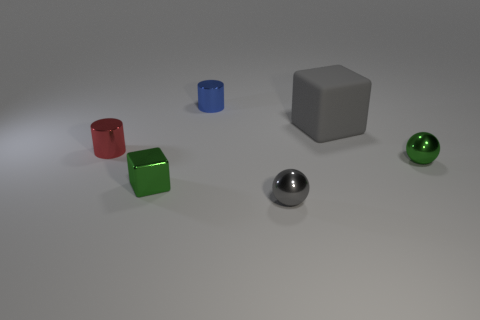How many tiny metal cylinders have the same color as the big rubber cube?
Keep it short and to the point. 0. Is the number of shiny cylinders in front of the red metal thing greater than the number of tiny objects?
Provide a short and direct response. No. There is a big thing that is in front of the metallic thing behind the large gray thing; what color is it?
Offer a terse response. Gray. What number of things are either metallic objects that are to the left of the green metal cube or small objects that are behind the small metal block?
Give a very brief answer. 3. The matte object has what color?
Offer a very short reply. Gray. How many cubes are the same material as the tiny red cylinder?
Offer a terse response. 1. Are there more small red shiny cylinders than red cubes?
Your answer should be compact. Yes. There is a green object left of the large gray cube; how many rubber cubes are in front of it?
Provide a short and direct response. 0. How many objects are small metallic cylinders in front of the big matte thing or large rubber cubes?
Give a very brief answer. 2. Are there any gray rubber objects that have the same shape as the tiny blue object?
Provide a succinct answer. No. 